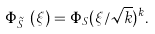Convert formula to latex. <formula><loc_0><loc_0><loc_500><loc_500>\Phi _ { \tilde { S } _ { k } } ( \xi ) = \Phi _ { S } ( \xi / \sqrt { k } ) ^ { k } .</formula> 